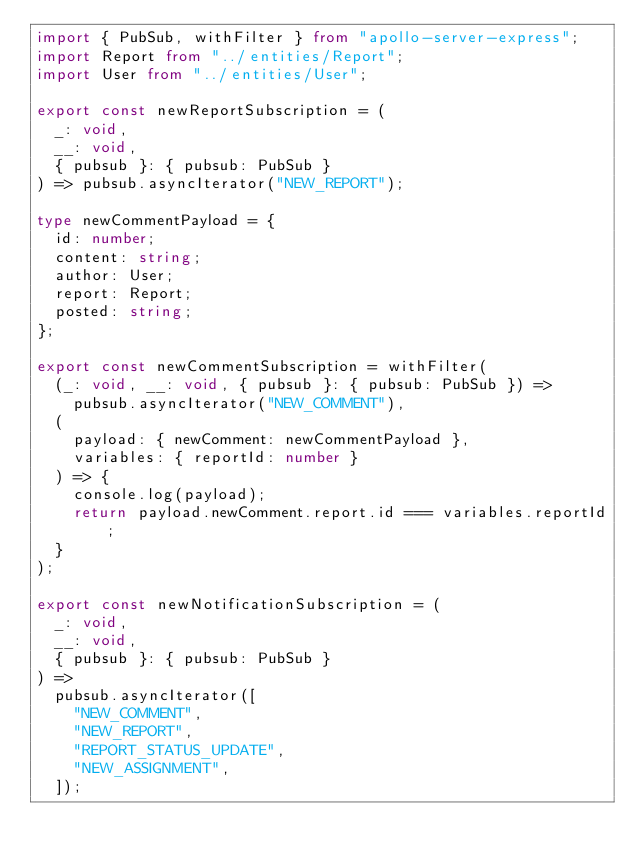<code> <loc_0><loc_0><loc_500><loc_500><_TypeScript_>import { PubSub, withFilter } from "apollo-server-express";
import Report from "../entities/Report";
import User from "../entities/User";

export const newReportSubscription = (
  _: void,
  __: void,
  { pubsub }: { pubsub: PubSub }
) => pubsub.asyncIterator("NEW_REPORT");

type newCommentPayload = {
  id: number;
  content: string;
  author: User;
  report: Report;
  posted: string;
};

export const newCommentSubscription = withFilter(
  (_: void, __: void, { pubsub }: { pubsub: PubSub }) =>
    pubsub.asyncIterator("NEW_COMMENT"),
  (
    payload: { newComment: newCommentPayload },
    variables: { reportId: number }
  ) => {
    console.log(payload);
    return payload.newComment.report.id === variables.reportId;
  }
);

export const newNotificationSubscription = (
  _: void,
  __: void,
  { pubsub }: { pubsub: PubSub }
) =>
  pubsub.asyncIterator([
    "NEW_COMMENT",
    "NEW_REPORT",
    "REPORT_STATUS_UPDATE",
    "NEW_ASSIGNMENT",
  ]);
</code> 